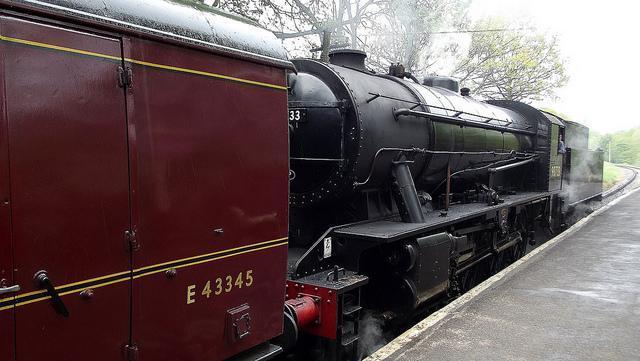How many trains are there?
Give a very brief answer. 1. 